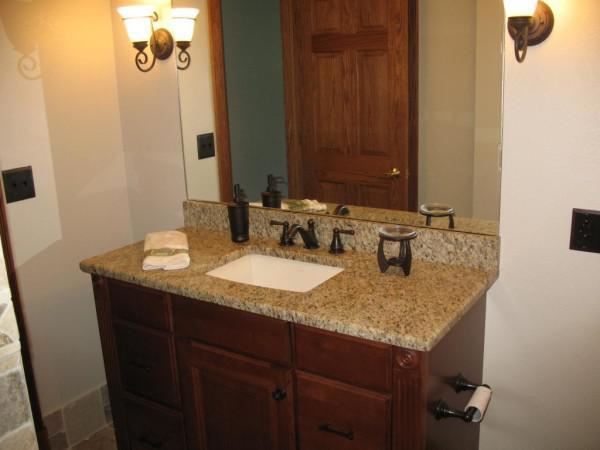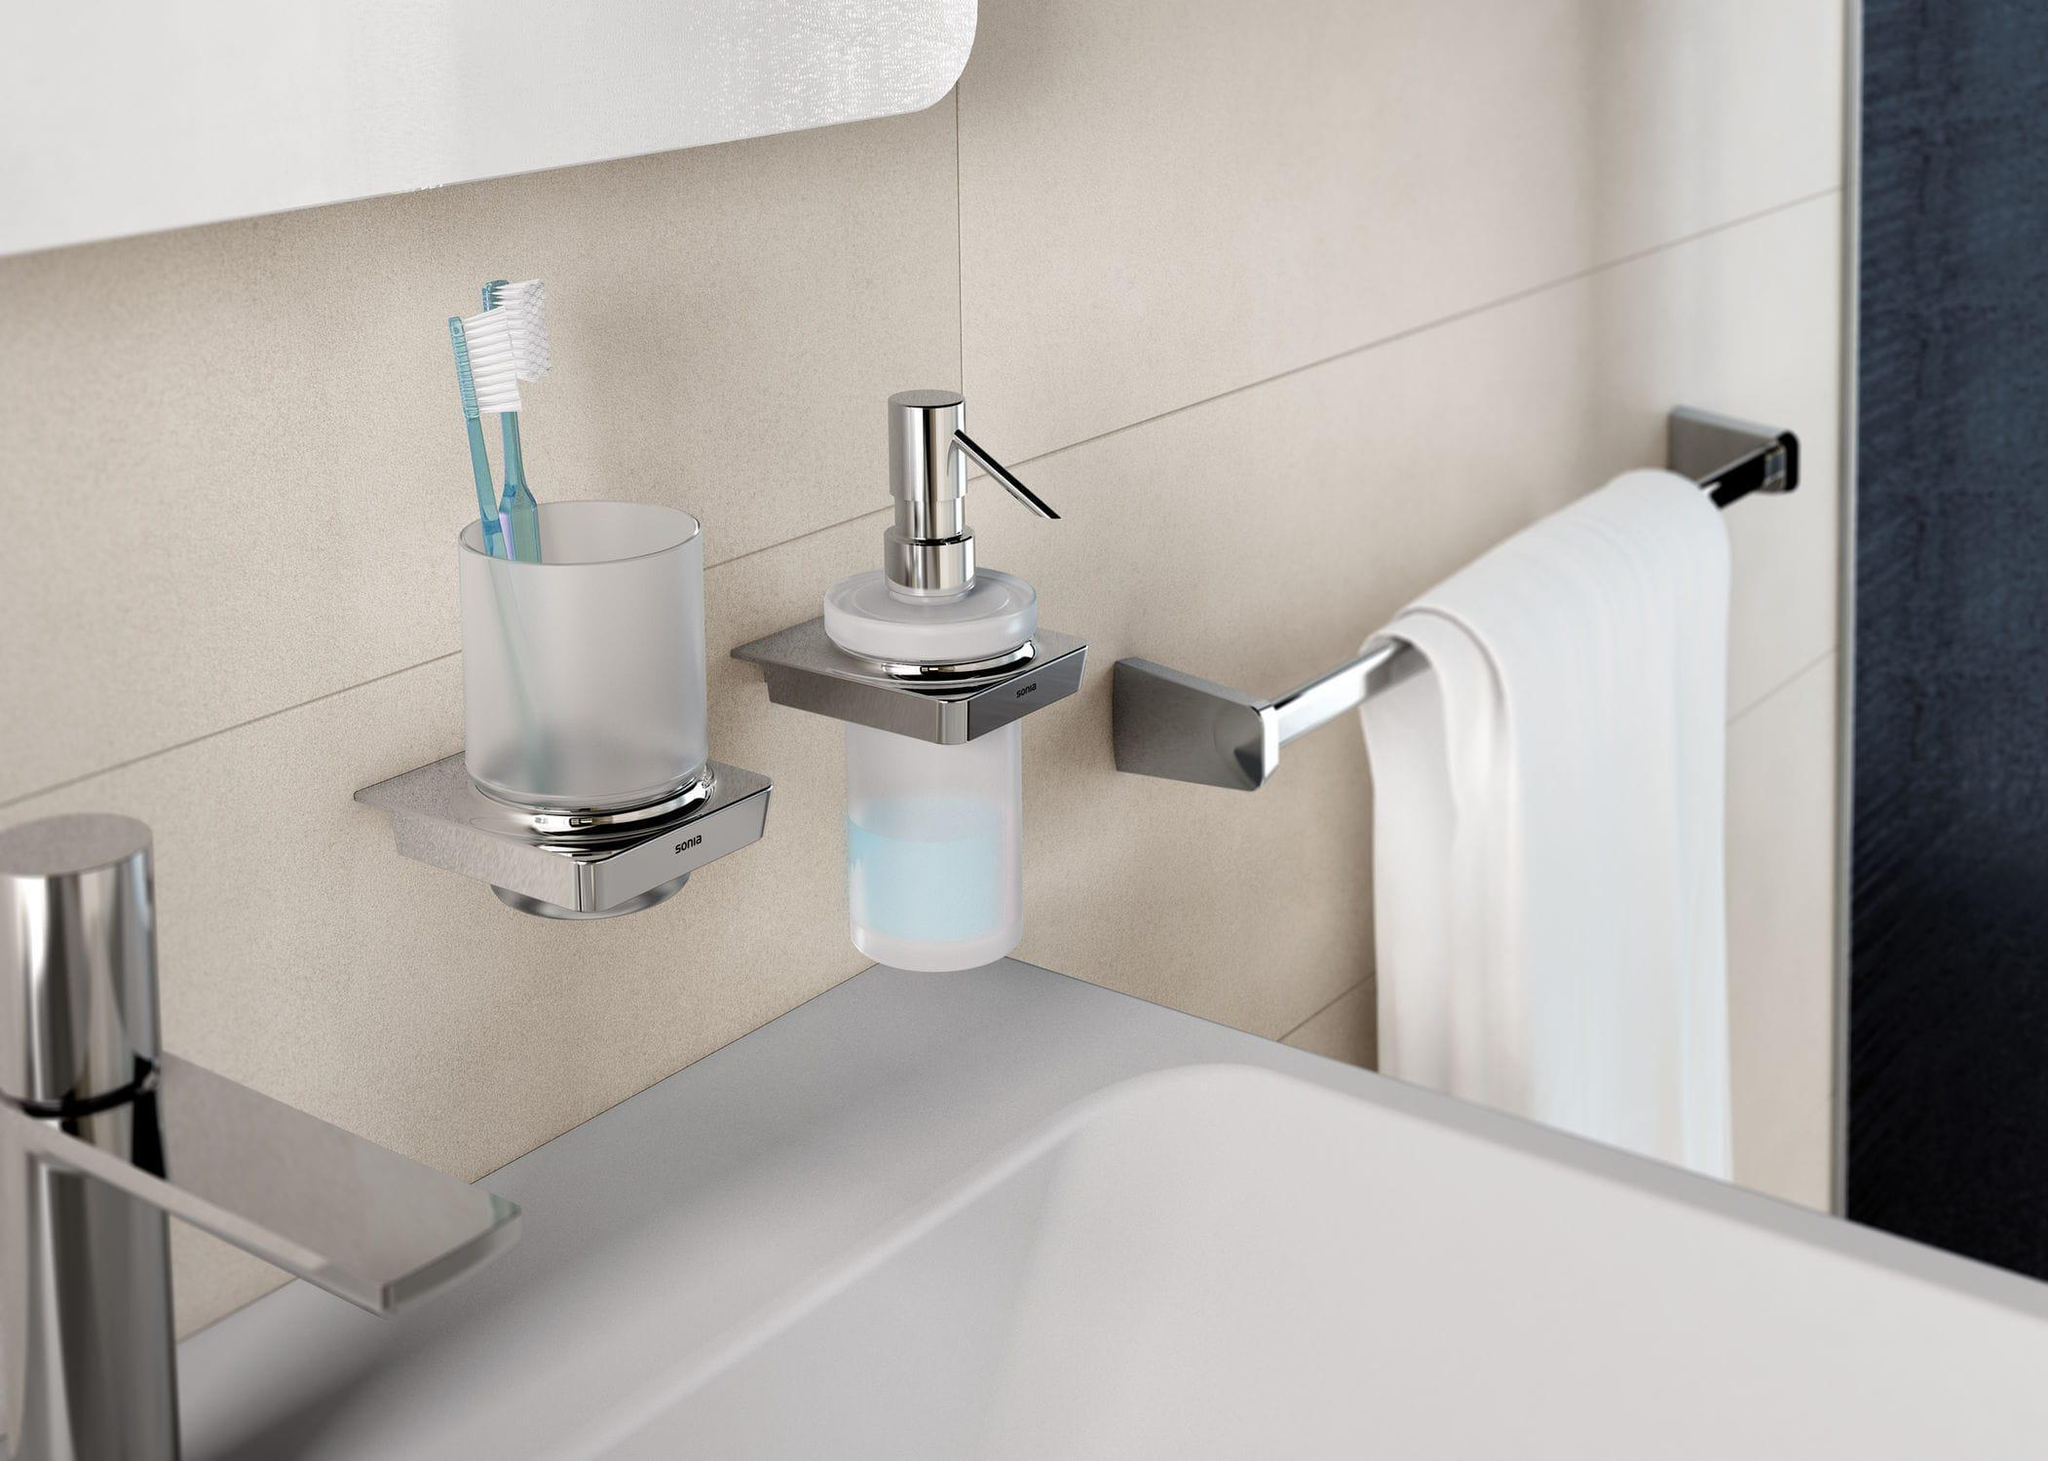The first image is the image on the left, the second image is the image on the right. Considering the images on both sides, is "there is a white square shaped sink with a chrome faucet and a vase of flowers next to it" valid? Answer yes or no. No. 